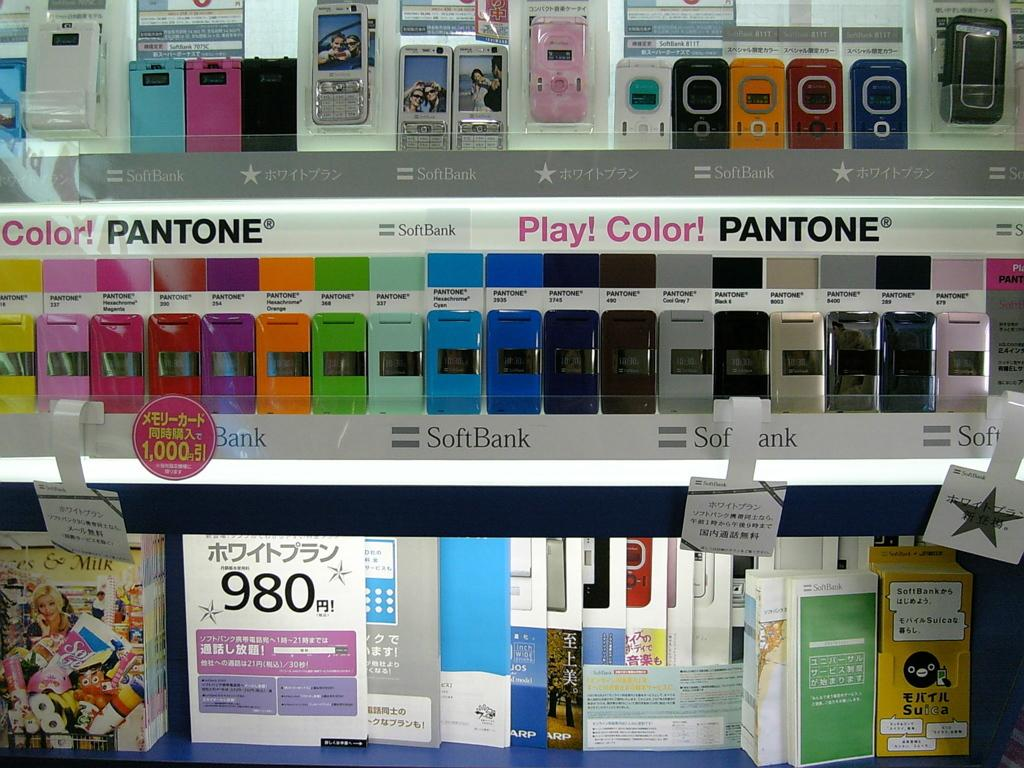<image>
Summarize the visual content of the image. a stand of colorful phones next to each other with a sign that says 'color!pantone' on it 